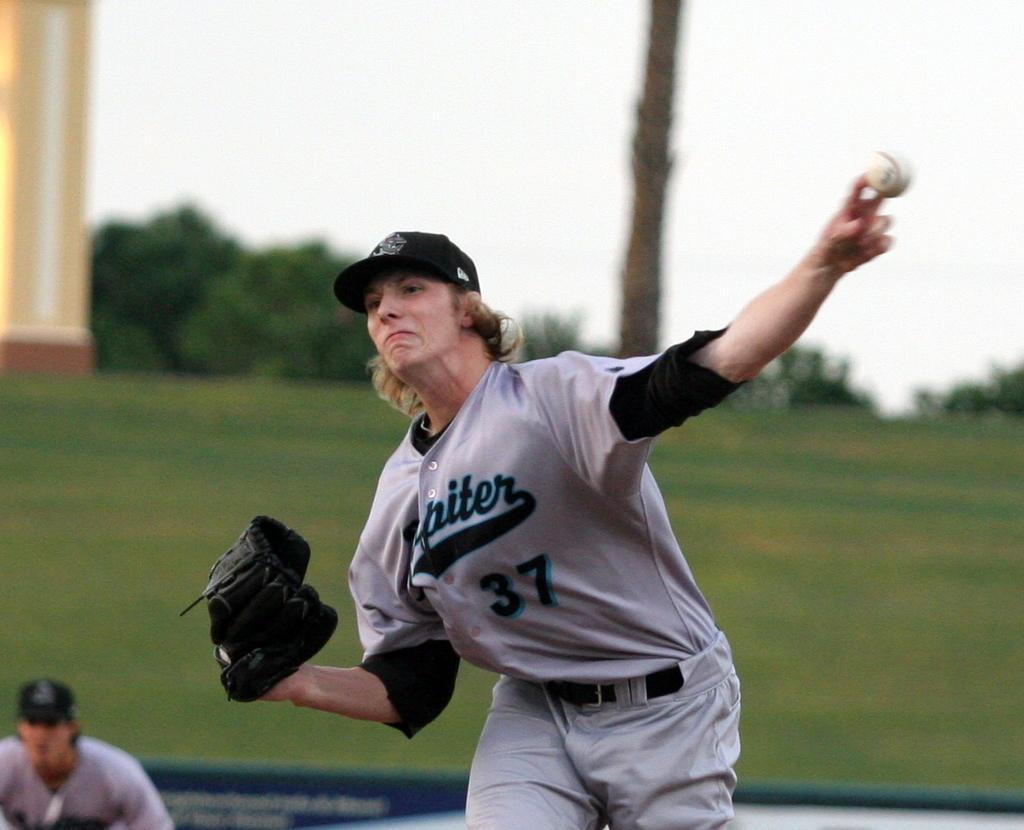Describe this image in one or two sentences. In this image a person wearing a sports dress. He is having gloves in one hand and throwing a ball with other hand. He is wearing a cap. Left bottom there is a person wearing a cap. Behind him there is a fence. In background there are few trees and poles on the grass land. Top of image there is sky. 